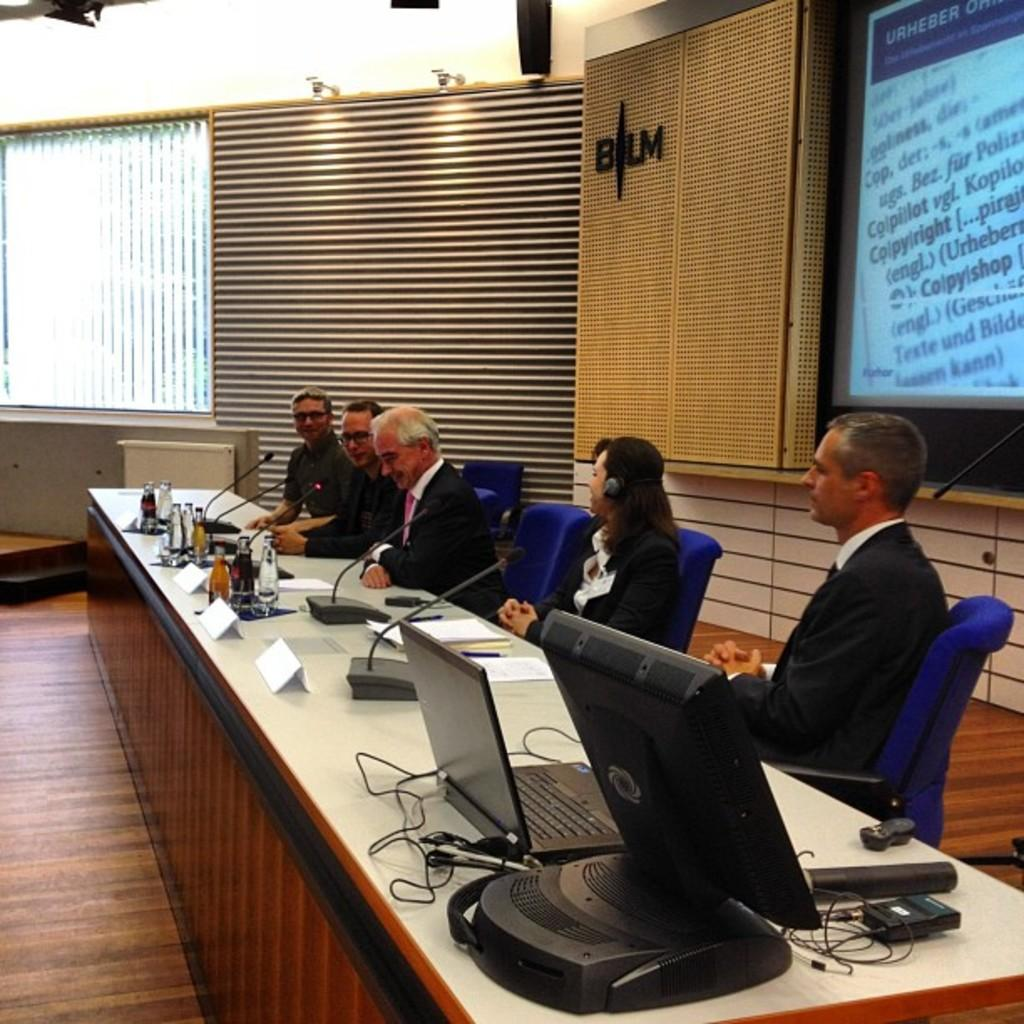<image>
Render a clear and concise summary of the photo. People in a meeting with the definition of copyright on the screen. 